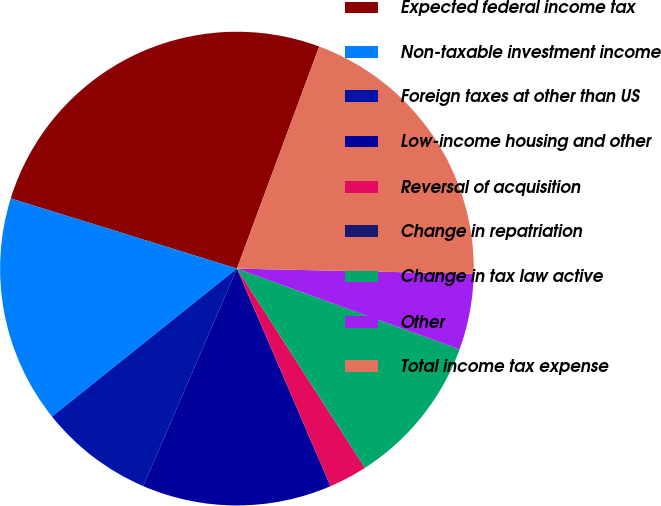Convert chart. <chart><loc_0><loc_0><loc_500><loc_500><pie_chart><fcel>Expected federal income tax<fcel>Non-taxable investment income<fcel>Foreign taxes at other than US<fcel>Low-income housing and other<fcel>Reversal of acquisition<fcel>Change in repatriation<fcel>Change in tax law active<fcel>Other<fcel>Total income tax expense<nl><fcel>25.86%<fcel>15.53%<fcel>7.78%<fcel>12.94%<fcel>2.61%<fcel>0.03%<fcel>10.36%<fcel>5.19%<fcel>19.7%<nl></chart> 